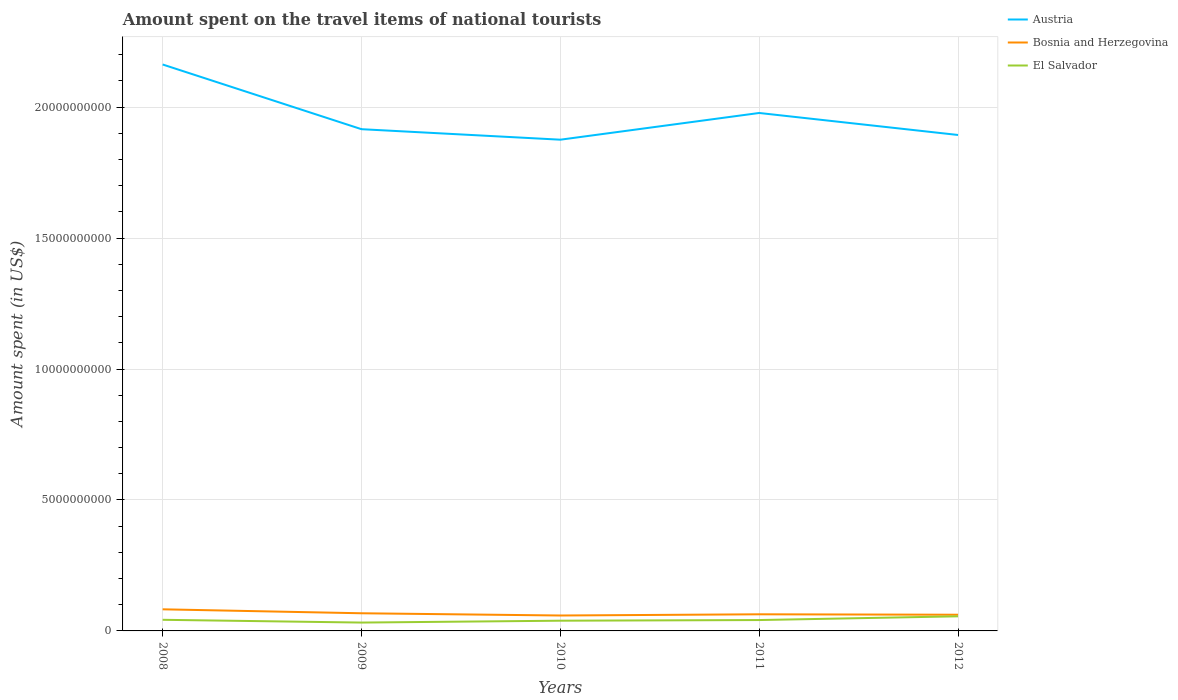How many different coloured lines are there?
Your answer should be very brief. 3. Is the number of lines equal to the number of legend labels?
Your answer should be very brief. Yes. Across all years, what is the maximum amount spent on the travel items of national tourists in El Salvador?
Your answer should be very brief. 3.19e+08. In which year was the amount spent on the travel items of national tourists in Austria maximum?
Offer a terse response. 2010. What is the total amount spent on the travel items of national tourists in El Salvador in the graph?
Provide a short and direct response. -2.39e+08. What is the difference between the highest and the second highest amount spent on the travel items of national tourists in Bosnia and Herzegovina?
Make the answer very short. 2.36e+08. What is the difference between the highest and the lowest amount spent on the travel items of national tourists in Austria?
Keep it short and to the point. 2. What is the difference between two consecutive major ticks on the Y-axis?
Keep it short and to the point. 5.00e+09. Does the graph contain any zero values?
Offer a terse response. No. Does the graph contain grids?
Make the answer very short. Yes. How many legend labels are there?
Give a very brief answer. 3. How are the legend labels stacked?
Ensure brevity in your answer.  Vertical. What is the title of the graph?
Offer a very short reply. Amount spent on the travel items of national tourists. What is the label or title of the X-axis?
Provide a succinct answer. Years. What is the label or title of the Y-axis?
Ensure brevity in your answer.  Amount spent (in US$). What is the Amount spent (in US$) of Austria in 2008?
Provide a short and direct response. 2.16e+1. What is the Amount spent (in US$) in Bosnia and Herzegovina in 2008?
Offer a terse response. 8.25e+08. What is the Amount spent (in US$) in El Salvador in 2008?
Provide a succinct answer. 4.25e+08. What is the Amount spent (in US$) in Austria in 2009?
Provide a succinct answer. 1.92e+1. What is the Amount spent (in US$) in Bosnia and Herzegovina in 2009?
Give a very brief answer. 6.74e+08. What is the Amount spent (in US$) in El Salvador in 2009?
Your response must be concise. 3.19e+08. What is the Amount spent (in US$) in Austria in 2010?
Offer a terse response. 1.88e+1. What is the Amount spent (in US$) in Bosnia and Herzegovina in 2010?
Offer a very short reply. 5.89e+08. What is the Amount spent (in US$) of El Salvador in 2010?
Ensure brevity in your answer.  3.90e+08. What is the Amount spent (in US$) of Austria in 2011?
Give a very brief answer. 1.98e+1. What is the Amount spent (in US$) of Bosnia and Herzegovina in 2011?
Give a very brief answer. 6.35e+08. What is the Amount spent (in US$) in El Salvador in 2011?
Provide a short and direct response. 4.15e+08. What is the Amount spent (in US$) of Austria in 2012?
Offer a terse response. 1.89e+1. What is the Amount spent (in US$) of Bosnia and Herzegovina in 2012?
Your answer should be very brief. 6.18e+08. What is the Amount spent (in US$) of El Salvador in 2012?
Provide a succinct answer. 5.58e+08. Across all years, what is the maximum Amount spent (in US$) in Austria?
Offer a very short reply. 2.16e+1. Across all years, what is the maximum Amount spent (in US$) in Bosnia and Herzegovina?
Make the answer very short. 8.25e+08. Across all years, what is the maximum Amount spent (in US$) of El Salvador?
Make the answer very short. 5.58e+08. Across all years, what is the minimum Amount spent (in US$) in Austria?
Keep it short and to the point. 1.88e+1. Across all years, what is the minimum Amount spent (in US$) of Bosnia and Herzegovina?
Your answer should be very brief. 5.89e+08. Across all years, what is the minimum Amount spent (in US$) of El Salvador?
Your answer should be compact. 3.19e+08. What is the total Amount spent (in US$) in Austria in the graph?
Ensure brevity in your answer.  9.83e+1. What is the total Amount spent (in US$) in Bosnia and Herzegovina in the graph?
Provide a short and direct response. 3.34e+09. What is the total Amount spent (in US$) of El Salvador in the graph?
Your answer should be compact. 2.11e+09. What is the difference between the Amount spent (in US$) in Austria in 2008 and that in 2009?
Your answer should be compact. 2.47e+09. What is the difference between the Amount spent (in US$) in Bosnia and Herzegovina in 2008 and that in 2009?
Provide a succinct answer. 1.51e+08. What is the difference between the Amount spent (in US$) in El Salvador in 2008 and that in 2009?
Keep it short and to the point. 1.06e+08. What is the difference between the Amount spent (in US$) of Austria in 2008 and that in 2010?
Keep it short and to the point. 2.87e+09. What is the difference between the Amount spent (in US$) in Bosnia and Herzegovina in 2008 and that in 2010?
Offer a very short reply. 2.36e+08. What is the difference between the Amount spent (in US$) of El Salvador in 2008 and that in 2010?
Your answer should be very brief. 3.50e+07. What is the difference between the Amount spent (in US$) of Austria in 2008 and that in 2011?
Offer a very short reply. 1.85e+09. What is the difference between the Amount spent (in US$) of Bosnia and Herzegovina in 2008 and that in 2011?
Make the answer very short. 1.90e+08. What is the difference between the Amount spent (in US$) in Austria in 2008 and that in 2012?
Your response must be concise. 2.69e+09. What is the difference between the Amount spent (in US$) of Bosnia and Herzegovina in 2008 and that in 2012?
Offer a very short reply. 2.07e+08. What is the difference between the Amount spent (in US$) in El Salvador in 2008 and that in 2012?
Provide a succinct answer. -1.33e+08. What is the difference between the Amount spent (in US$) in Austria in 2009 and that in 2010?
Ensure brevity in your answer.  4.01e+08. What is the difference between the Amount spent (in US$) of Bosnia and Herzegovina in 2009 and that in 2010?
Ensure brevity in your answer.  8.50e+07. What is the difference between the Amount spent (in US$) of El Salvador in 2009 and that in 2010?
Ensure brevity in your answer.  -7.10e+07. What is the difference between the Amount spent (in US$) in Austria in 2009 and that in 2011?
Your answer should be very brief. -6.19e+08. What is the difference between the Amount spent (in US$) in Bosnia and Herzegovina in 2009 and that in 2011?
Your answer should be compact. 3.90e+07. What is the difference between the Amount spent (in US$) in El Salvador in 2009 and that in 2011?
Provide a short and direct response. -9.60e+07. What is the difference between the Amount spent (in US$) in Austria in 2009 and that in 2012?
Provide a succinct answer. 2.21e+08. What is the difference between the Amount spent (in US$) in Bosnia and Herzegovina in 2009 and that in 2012?
Your response must be concise. 5.60e+07. What is the difference between the Amount spent (in US$) in El Salvador in 2009 and that in 2012?
Provide a succinct answer. -2.39e+08. What is the difference between the Amount spent (in US$) in Austria in 2010 and that in 2011?
Your answer should be very brief. -1.02e+09. What is the difference between the Amount spent (in US$) of Bosnia and Herzegovina in 2010 and that in 2011?
Your answer should be compact. -4.60e+07. What is the difference between the Amount spent (in US$) of El Salvador in 2010 and that in 2011?
Offer a terse response. -2.50e+07. What is the difference between the Amount spent (in US$) of Austria in 2010 and that in 2012?
Keep it short and to the point. -1.80e+08. What is the difference between the Amount spent (in US$) of Bosnia and Herzegovina in 2010 and that in 2012?
Offer a terse response. -2.90e+07. What is the difference between the Amount spent (in US$) of El Salvador in 2010 and that in 2012?
Provide a short and direct response. -1.68e+08. What is the difference between the Amount spent (in US$) in Austria in 2011 and that in 2012?
Your answer should be very brief. 8.40e+08. What is the difference between the Amount spent (in US$) of Bosnia and Herzegovina in 2011 and that in 2012?
Your answer should be very brief. 1.70e+07. What is the difference between the Amount spent (in US$) of El Salvador in 2011 and that in 2012?
Your response must be concise. -1.43e+08. What is the difference between the Amount spent (in US$) in Austria in 2008 and the Amount spent (in US$) in Bosnia and Herzegovina in 2009?
Give a very brief answer. 2.10e+1. What is the difference between the Amount spent (in US$) in Austria in 2008 and the Amount spent (in US$) in El Salvador in 2009?
Ensure brevity in your answer.  2.13e+1. What is the difference between the Amount spent (in US$) in Bosnia and Herzegovina in 2008 and the Amount spent (in US$) in El Salvador in 2009?
Provide a short and direct response. 5.06e+08. What is the difference between the Amount spent (in US$) of Austria in 2008 and the Amount spent (in US$) of Bosnia and Herzegovina in 2010?
Provide a short and direct response. 2.10e+1. What is the difference between the Amount spent (in US$) of Austria in 2008 and the Amount spent (in US$) of El Salvador in 2010?
Provide a short and direct response. 2.12e+1. What is the difference between the Amount spent (in US$) of Bosnia and Herzegovina in 2008 and the Amount spent (in US$) of El Salvador in 2010?
Ensure brevity in your answer.  4.35e+08. What is the difference between the Amount spent (in US$) of Austria in 2008 and the Amount spent (in US$) of Bosnia and Herzegovina in 2011?
Ensure brevity in your answer.  2.10e+1. What is the difference between the Amount spent (in US$) of Austria in 2008 and the Amount spent (in US$) of El Salvador in 2011?
Provide a succinct answer. 2.12e+1. What is the difference between the Amount spent (in US$) of Bosnia and Herzegovina in 2008 and the Amount spent (in US$) of El Salvador in 2011?
Give a very brief answer. 4.10e+08. What is the difference between the Amount spent (in US$) in Austria in 2008 and the Amount spent (in US$) in Bosnia and Herzegovina in 2012?
Keep it short and to the point. 2.10e+1. What is the difference between the Amount spent (in US$) in Austria in 2008 and the Amount spent (in US$) in El Salvador in 2012?
Provide a short and direct response. 2.11e+1. What is the difference between the Amount spent (in US$) of Bosnia and Herzegovina in 2008 and the Amount spent (in US$) of El Salvador in 2012?
Offer a very short reply. 2.67e+08. What is the difference between the Amount spent (in US$) in Austria in 2009 and the Amount spent (in US$) in Bosnia and Herzegovina in 2010?
Keep it short and to the point. 1.86e+1. What is the difference between the Amount spent (in US$) in Austria in 2009 and the Amount spent (in US$) in El Salvador in 2010?
Provide a succinct answer. 1.88e+1. What is the difference between the Amount spent (in US$) in Bosnia and Herzegovina in 2009 and the Amount spent (in US$) in El Salvador in 2010?
Provide a short and direct response. 2.84e+08. What is the difference between the Amount spent (in US$) of Austria in 2009 and the Amount spent (in US$) of Bosnia and Herzegovina in 2011?
Offer a very short reply. 1.85e+1. What is the difference between the Amount spent (in US$) in Austria in 2009 and the Amount spent (in US$) in El Salvador in 2011?
Provide a succinct answer. 1.87e+1. What is the difference between the Amount spent (in US$) in Bosnia and Herzegovina in 2009 and the Amount spent (in US$) in El Salvador in 2011?
Your answer should be compact. 2.59e+08. What is the difference between the Amount spent (in US$) in Austria in 2009 and the Amount spent (in US$) in Bosnia and Herzegovina in 2012?
Provide a short and direct response. 1.85e+1. What is the difference between the Amount spent (in US$) of Austria in 2009 and the Amount spent (in US$) of El Salvador in 2012?
Offer a very short reply. 1.86e+1. What is the difference between the Amount spent (in US$) of Bosnia and Herzegovina in 2009 and the Amount spent (in US$) of El Salvador in 2012?
Give a very brief answer. 1.16e+08. What is the difference between the Amount spent (in US$) of Austria in 2010 and the Amount spent (in US$) of Bosnia and Herzegovina in 2011?
Offer a terse response. 1.81e+1. What is the difference between the Amount spent (in US$) in Austria in 2010 and the Amount spent (in US$) in El Salvador in 2011?
Make the answer very short. 1.83e+1. What is the difference between the Amount spent (in US$) in Bosnia and Herzegovina in 2010 and the Amount spent (in US$) in El Salvador in 2011?
Ensure brevity in your answer.  1.74e+08. What is the difference between the Amount spent (in US$) of Austria in 2010 and the Amount spent (in US$) of Bosnia and Herzegovina in 2012?
Provide a short and direct response. 1.81e+1. What is the difference between the Amount spent (in US$) of Austria in 2010 and the Amount spent (in US$) of El Salvador in 2012?
Ensure brevity in your answer.  1.82e+1. What is the difference between the Amount spent (in US$) of Bosnia and Herzegovina in 2010 and the Amount spent (in US$) of El Salvador in 2012?
Keep it short and to the point. 3.10e+07. What is the difference between the Amount spent (in US$) of Austria in 2011 and the Amount spent (in US$) of Bosnia and Herzegovina in 2012?
Keep it short and to the point. 1.92e+1. What is the difference between the Amount spent (in US$) in Austria in 2011 and the Amount spent (in US$) in El Salvador in 2012?
Your response must be concise. 1.92e+1. What is the difference between the Amount spent (in US$) of Bosnia and Herzegovina in 2011 and the Amount spent (in US$) of El Salvador in 2012?
Give a very brief answer. 7.70e+07. What is the average Amount spent (in US$) in Austria per year?
Your response must be concise. 1.97e+1. What is the average Amount spent (in US$) of Bosnia and Herzegovina per year?
Provide a succinct answer. 6.68e+08. What is the average Amount spent (in US$) of El Salvador per year?
Make the answer very short. 4.21e+08. In the year 2008, what is the difference between the Amount spent (in US$) in Austria and Amount spent (in US$) in Bosnia and Herzegovina?
Your response must be concise. 2.08e+1. In the year 2008, what is the difference between the Amount spent (in US$) in Austria and Amount spent (in US$) in El Salvador?
Give a very brief answer. 2.12e+1. In the year 2008, what is the difference between the Amount spent (in US$) of Bosnia and Herzegovina and Amount spent (in US$) of El Salvador?
Provide a succinct answer. 4.00e+08. In the year 2009, what is the difference between the Amount spent (in US$) of Austria and Amount spent (in US$) of Bosnia and Herzegovina?
Provide a short and direct response. 1.85e+1. In the year 2009, what is the difference between the Amount spent (in US$) in Austria and Amount spent (in US$) in El Salvador?
Ensure brevity in your answer.  1.88e+1. In the year 2009, what is the difference between the Amount spent (in US$) in Bosnia and Herzegovina and Amount spent (in US$) in El Salvador?
Give a very brief answer. 3.55e+08. In the year 2010, what is the difference between the Amount spent (in US$) in Austria and Amount spent (in US$) in Bosnia and Herzegovina?
Your response must be concise. 1.82e+1. In the year 2010, what is the difference between the Amount spent (in US$) of Austria and Amount spent (in US$) of El Salvador?
Your answer should be very brief. 1.84e+1. In the year 2010, what is the difference between the Amount spent (in US$) of Bosnia and Herzegovina and Amount spent (in US$) of El Salvador?
Ensure brevity in your answer.  1.99e+08. In the year 2011, what is the difference between the Amount spent (in US$) in Austria and Amount spent (in US$) in Bosnia and Herzegovina?
Offer a very short reply. 1.91e+1. In the year 2011, what is the difference between the Amount spent (in US$) of Austria and Amount spent (in US$) of El Salvador?
Ensure brevity in your answer.  1.94e+1. In the year 2011, what is the difference between the Amount spent (in US$) of Bosnia and Herzegovina and Amount spent (in US$) of El Salvador?
Make the answer very short. 2.20e+08. In the year 2012, what is the difference between the Amount spent (in US$) in Austria and Amount spent (in US$) in Bosnia and Herzegovina?
Keep it short and to the point. 1.83e+1. In the year 2012, what is the difference between the Amount spent (in US$) in Austria and Amount spent (in US$) in El Salvador?
Offer a very short reply. 1.84e+1. In the year 2012, what is the difference between the Amount spent (in US$) in Bosnia and Herzegovina and Amount spent (in US$) in El Salvador?
Keep it short and to the point. 6.00e+07. What is the ratio of the Amount spent (in US$) of Austria in 2008 to that in 2009?
Offer a very short reply. 1.13. What is the ratio of the Amount spent (in US$) in Bosnia and Herzegovina in 2008 to that in 2009?
Provide a succinct answer. 1.22. What is the ratio of the Amount spent (in US$) of El Salvador in 2008 to that in 2009?
Provide a short and direct response. 1.33. What is the ratio of the Amount spent (in US$) in Austria in 2008 to that in 2010?
Provide a succinct answer. 1.15. What is the ratio of the Amount spent (in US$) of Bosnia and Herzegovina in 2008 to that in 2010?
Offer a terse response. 1.4. What is the ratio of the Amount spent (in US$) of El Salvador in 2008 to that in 2010?
Give a very brief answer. 1.09. What is the ratio of the Amount spent (in US$) in Austria in 2008 to that in 2011?
Offer a terse response. 1.09. What is the ratio of the Amount spent (in US$) of Bosnia and Herzegovina in 2008 to that in 2011?
Provide a succinct answer. 1.3. What is the ratio of the Amount spent (in US$) of El Salvador in 2008 to that in 2011?
Your answer should be compact. 1.02. What is the ratio of the Amount spent (in US$) in Austria in 2008 to that in 2012?
Your answer should be very brief. 1.14. What is the ratio of the Amount spent (in US$) in Bosnia and Herzegovina in 2008 to that in 2012?
Offer a very short reply. 1.33. What is the ratio of the Amount spent (in US$) in El Salvador in 2008 to that in 2012?
Your answer should be very brief. 0.76. What is the ratio of the Amount spent (in US$) in Austria in 2009 to that in 2010?
Keep it short and to the point. 1.02. What is the ratio of the Amount spent (in US$) in Bosnia and Herzegovina in 2009 to that in 2010?
Provide a short and direct response. 1.14. What is the ratio of the Amount spent (in US$) in El Salvador in 2009 to that in 2010?
Your response must be concise. 0.82. What is the ratio of the Amount spent (in US$) in Austria in 2009 to that in 2011?
Provide a short and direct response. 0.97. What is the ratio of the Amount spent (in US$) of Bosnia and Herzegovina in 2009 to that in 2011?
Give a very brief answer. 1.06. What is the ratio of the Amount spent (in US$) in El Salvador in 2009 to that in 2011?
Provide a succinct answer. 0.77. What is the ratio of the Amount spent (in US$) in Austria in 2009 to that in 2012?
Your answer should be compact. 1.01. What is the ratio of the Amount spent (in US$) in Bosnia and Herzegovina in 2009 to that in 2012?
Your answer should be very brief. 1.09. What is the ratio of the Amount spent (in US$) of El Salvador in 2009 to that in 2012?
Keep it short and to the point. 0.57. What is the ratio of the Amount spent (in US$) in Austria in 2010 to that in 2011?
Keep it short and to the point. 0.95. What is the ratio of the Amount spent (in US$) of Bosnia and Herzegovina in 2010 to that in 2011?
Make the answer very short. 0.93. What is the ratio of the Amount spent (in US$) of El Salvador in 2010 to that in 2011?
Your answer should be compact. 0.94. What is the ratio of the Amount spent (in US$) of Bosnia and Herzegovina in 2010 to that in 2012?
Make the answer very short. 0.95. What is the ratio of the Amount spent (in US$) of El Salvador in 2010 to that in 2012?
Keep it short and to the point. 0.7. What is the ratio of the Amount spent (in US$) of Austria in 2011 to that in 2012?
Offer a terse response. 1.04. What is the ratio of the Amount spent (in US$) of Bosnia and Herzegovina in 2011 to that in 2012?
Your answer should be compact. 1.03. What is the ratio of the Amount spent (in US$) in El Salvador in 2011 to that in 2012?
Provide a short and direct response. 0.74. What is the difference between the highest and the second highest Amount spent (in US$) in Austria?
Keep it short and to the point. 1.85e+09. What is the difference between the highest and the second highest Amount spent (in US$) in Bosnia and Herzegovina?
Provide a short and direct response. 1.51e+08. What is the difference between the highest and the second highest Amount spent (in US$) in El Salvador?
Offer a very short reply. 1.33e+08. What is the difference between the highest and the lowest Amount spent (in US$) in Austria?
Make the answer very short. 2.87e+09. What is the difference between the highest and the lowest Amount spent (in US$) in Bosnia and Herzegovina?
Your answer should be compact. 2.36e+08. What is the difference between the highest and the lowest Amount spent (in US$) in El Salvador?
Offer a terse response. 2.39e+08. 